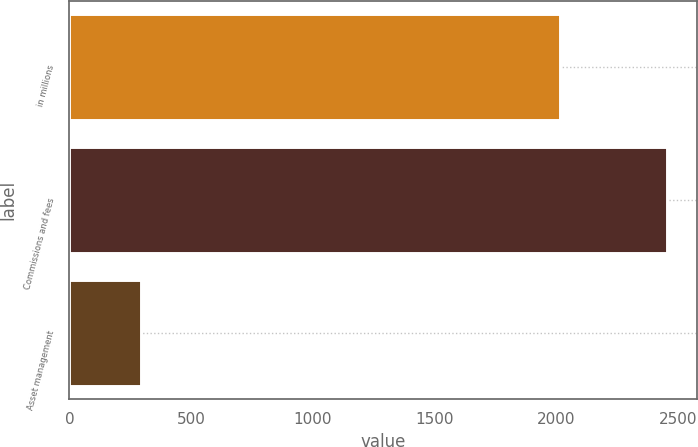Convert chart. <chart><loc_0><loc_0><loc_500><loc_500><bar_chart><fcel>in millions<fcel>Commissions and fees<fcel>Asset management<nl><fcel>2016<fcel>2456<fcel>293<nl></chart> 